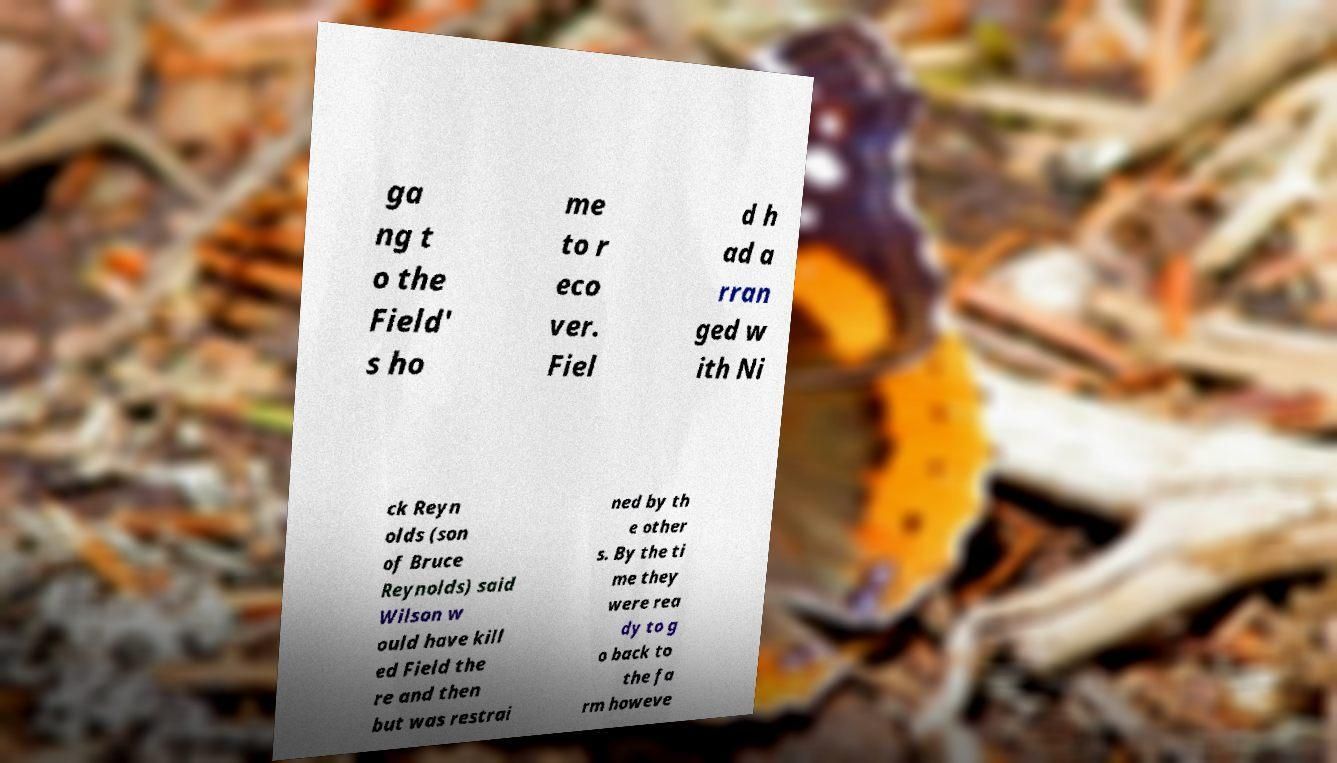Please identify and transcribe the text found in this image. ga ng t o the Field' s ho me to r eco ver. Fiel d h ad a rran ged w ith Ni ck Reyn olds (son of Bruce Reynolds) said Wilson w ould have kill ed Field the re and then but was restrai ned by th e other s. By the ti me they were rea dy to g o back to the fa rm howeve 